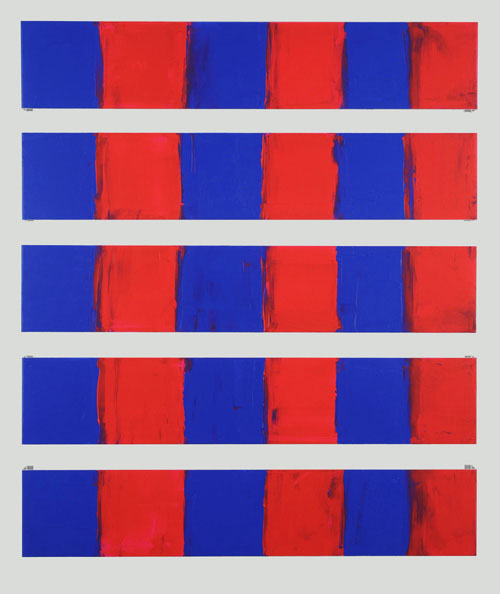What if this artwork were meant to illustrate a story? What story might it tell? If this artwork were meant to illustrate a story, it might tell a tale of contrasting emotions and dualities. The red and blue sections could represent two opposing forces or characters, each vying for dominance in a perpetual struggle. The overlapping of red over blue might suggest moments of conflict where passion takes over reason, while the orderly arrangement of the panels could indicate that despite these clashes, there remains an underlying structure or balance to it all. This could be the story of a battle between heart and mind, chaos and order, or even two individuals with contrasting ideologies. 